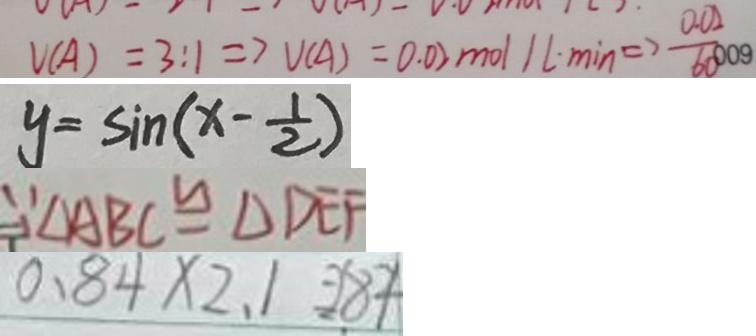Convert formula to latex. <formula><loc_0><loc_0><loc_500><loc_500>V ( A ) = 3 : 1 \Rightarrow V ( A ) = 0 . 0 2 m o l 1 L \cdot \min \Rightarrow \frac { 0 . 0 2 } { 6 0 } 
 y = \sin ( x - \frac { 1 } { 2 } ) 
 \because \Delta A B C \cong \Delta D E F 
 0 . 8 4 \times 2 . 1 = 2 . 8 4</formula> 